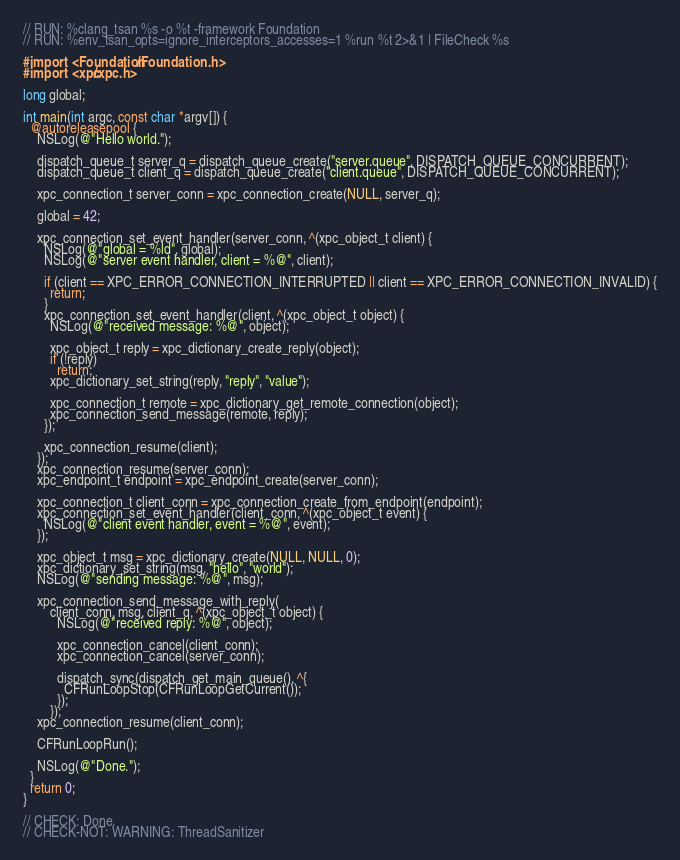Convert code to text. <code><loc_0><loc_0><loc_500><loc_500><_ObjectiveC_>// RUN: %clang_tsan %s -o %t -framework Foundation
// RUN: %env_tsan_opts=ignore_interceptors_accesses=1 %run %t 2>&1 | FileCheck %s

#import <Foundation/Foundation.h>
#import <xpc/xpc.h>

long global;

int main(int argc, const char *argv[]) {
  @autoreleasepool {
    NSLog(@"Hello world.");

    dispatch_queue_t server_q = dispatch_queue_create("server.queue", DISPATCH_QUEUE_CONCURRENT);
    dispatch_queue_t client_q = dispatch_queue_create("client.queue", DISPATCH_QUEUE_CONCURRENT);

    xpc_connection_t server_conn = xpc_connection_create(NULL, server_q);

    global = 42;

    xpc_connection_set_event_handler(server_conn, ^(xpc_object_t client) {
      NSLog(@"global = %ld", global);
      NSLog(@"server event handler, client = %@", client);

      if (client == XPC_ERROR_CONNECTION_INTERRUPTED || client == XPC_ERROR_CONNECTION_INVALID) {
        return;
      }
      xpc_connection_set_event_handler(client, ^(xpc_object_t object) {
        NSLog(@"received message: %@", object);

        xpc_object_t reply = xpc_dictionary_create_reply(object);
        if (!reply)
          return;
        xpc_dictionary_set_string(reply, "reply", "value");

        xpc_connection_t remote = xpc_dictionary_get_remote_connection(object);
        xpc_connection_send_message(remote, reply);
      });

      xpc_connection_resume(client);
    });
    xpc_connection_resume(server_conn);
    xpc_endpoint_t endpoint = xpc_endpoint_create(server_conn);

    xpc_connection_t client_conn = xpc_connection_create_from_endpoint(endpoint);
    xpc_connection_set_event_handler(client_conn, ^(xpc_object_t event) {
      NSLog(@"client event handler, event = %@", event);
    });

    xpc_object_t msg = xpc_dictionary_create(NULL, NULL, 0);
    xpc_dictionary_set_string(msg, "hello", "world");
    NSLog(@"sending message: %@", msg);

    xpc_connection_send_message_with_reply(
        client_conn, msg, client_q, ^(xpc_object_t object) {
          NSLog(@"received reply: %@", object);

          xpc_connection_cancel(client_conn);
          xpc_connection_cancel(server_conn);

          dispatch_sync(dispatch_get_main_queue(), ^{
            CFRunLoopStop(CFRunLoopGetCurrent());
          });
        });
    xpc_connection_resume(client_conn);

    CFRunLoopRun();

    NSLog(@"Done.");
  }
  return 0;
}

// CHECK: Done.
// CHECK-NOT: WARNING: ThreadSanitizer
</code> 